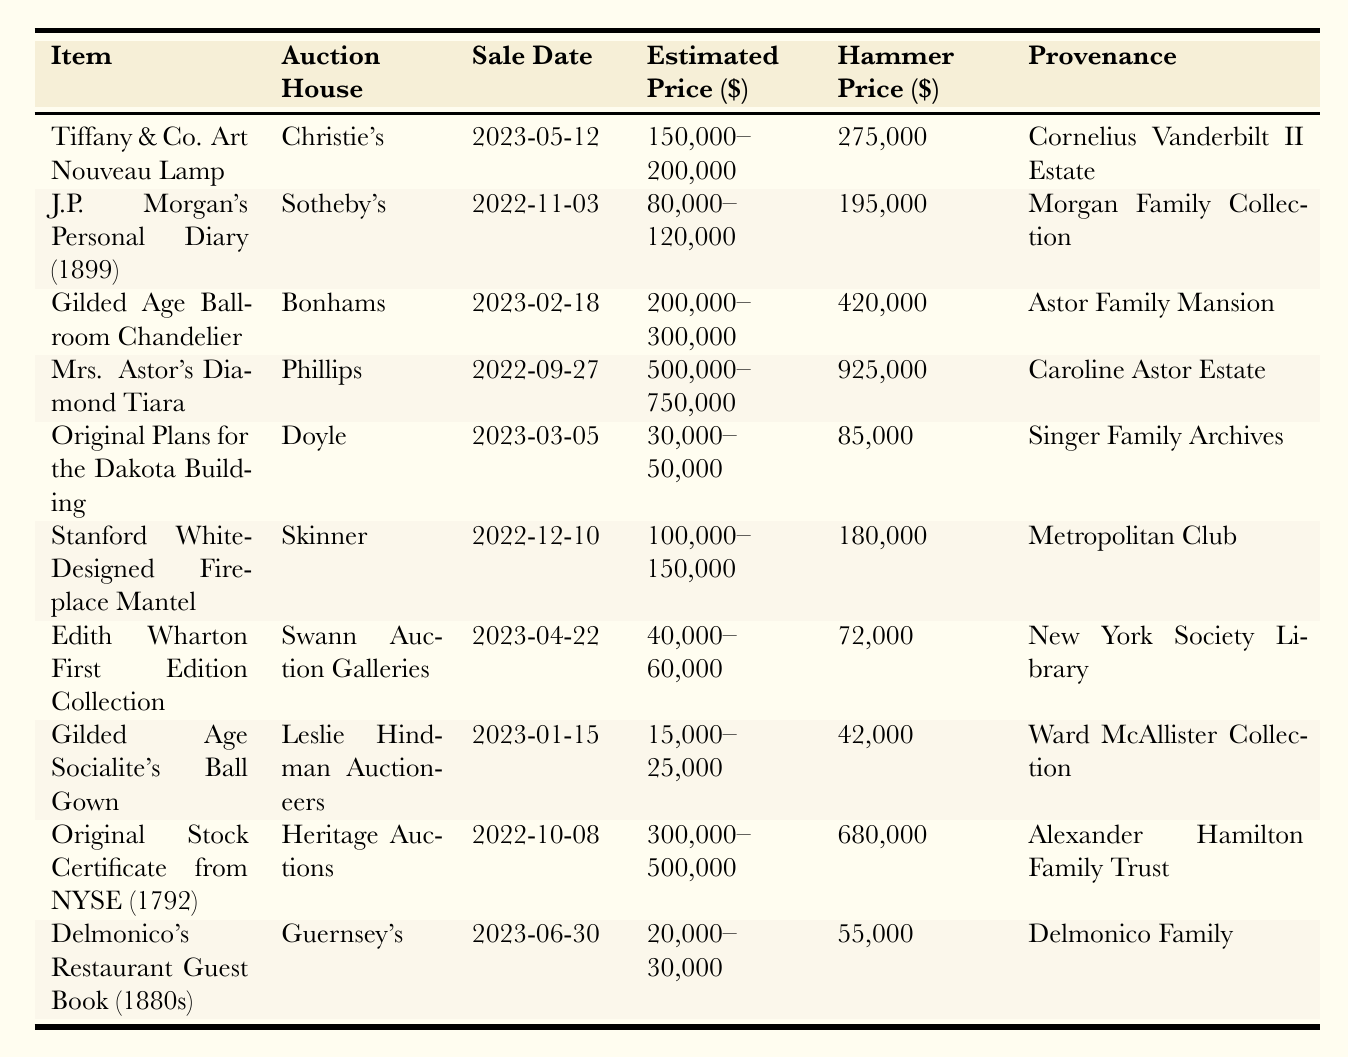What is the hammer price of Mrs. Astor's Diamond Tiara? The table shows that the hammer price for Mrs. Astor's Diamond Tiara, auctioned by Phillips on September 27, 2022, is 925,000.
Answer: 925,000 Which auction house sold the Tiffany & Co. Art Nouveau Lamp? According to the table, the Tiffany & Co. Art Nouveau Lamp was sold by Christie's.
Answer: Christie's What is the difference between the estimated price and the hammer price for the Gilded Age Ballroom Chandelier? The estimated price for the Gilded Age Ballroom Chandelier ranges from 200,000 to 300,000, and the hammer price is 420,000. To find the difference, we can take 420,000 and subtract the upper limit of the estimated price (300,000), which results in 120,000.
Answer: 120,000 Was the hammer price for the Original Stock Certificate from NYSE more than the maximum estimated price? The maximum estimated price for the Original Stock Certificate from NYSE is 500,000, and the hammer price is 680,000. Since 680,000 is greater than 500,000, the answer is yes.
Answer: Yes What item had the highest hammer price, and what was that price? From reviewing the hammer prices in the table, Mrs. Astor's Diamond Tiara has the highest value at 925,000.
Answer: Mrs. Astor's Diamond Tiara, 925,000 How many items were auctioned in the year 2023? The table lists 5 items that have auction dates in 2023. Counting them directly, we find they are the Tiffany & Co. Art Nouveau Lamp, Gilded Age Ballroom Chandelier, Edith Wharton First Edition Collection, Gilded Age Socialite's Ball Gown, and Delmonico's Restaurant Guest Book.
Answer: 5 What is the total estimated price range for all items auctioned at Sotheby's? The estimated price range for items auctioned at Sotheby's includes J.P. Morgan's Personal Diary (80,000 - 120,000). The total estimated range is the sum of these two values, which is 200,000 (80,000 + 120,000). Therefore, it is 200,000.
Answer: 200,000 Which item is associated with the Astor Family Mansion? The table indicates that the Gilded Age Ballroom Chandelier is linked to the Astor Family Mansion.
Answer: Gilded Age Ballroom Chandelier Calculate the average hammer price of items sold by Guernsey's and Heritage Auctions. Guernsey's sold the Delmonico's Restaurant Guest Book for 55,000, and Heritage Auctions sold the Original Stock Certificate from NYSE for 680,000. The sum of these prices is 735,000 (55,000 + 680,000), and since there are 2 items, the average is 735,000 divided by 2, yielding 367,500.
Answer: 367,500 Did any item sell for more than double its estimated price? Analyzing the items, the hammer price for Mrs. Astor's Diamond Tiara is 925,000, with an estimated range of 500,000 to 750,000. 925,000 is more than double the maximum estimated price of 750,000, so the answer is yes.
Answer: Yes 